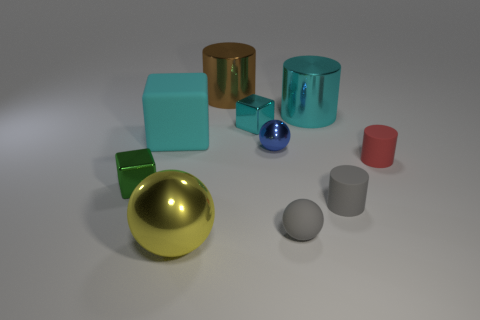Are the big brown object that is behind the tiny gray cylinder and the cyan cube that is on the left side of the big yellow shiny object made of the same material?
Ensure brevity in your answer.  No. What number of cylinders are the same color as the big matte block?
Offer a terse response. 1. What is the shape of the cyan thing that is both to the left of the gray matte sphere and right of the brown metallic cylinder?
Offer a terse response. Cube. There is a matte thing that is both behind the small green shiny object and right of the large brown cylinder; what color is it?
Offer a very short reply. Red. Is the number of large metallic things that are in front of the tiny gray cylinder greater than the number of small red things that are behind the brown metal thing?
Give a very brief answer. Yes. There is a metal ball that is behind the small rubber sphere; what is its color?
Keep it short and to the point. Blue. There is a matte object that is to the left of the big brown shiny thing; is it the same shape as the cyan shiny thing on the left side of the blue thing?
Ensure brevity in your answer.  Yes. Is there a brown cylinder of the same size as the yellow ball?
Your answer should be very brief. Yes. What is the small gray object behind the tiny gray ball made of?
Provide a succinct answer. Rubber. Are the small cube that is in front of the red matte cylinder and the tiny cyan thing made of the same material?
Offer a very short reply. Yes. 